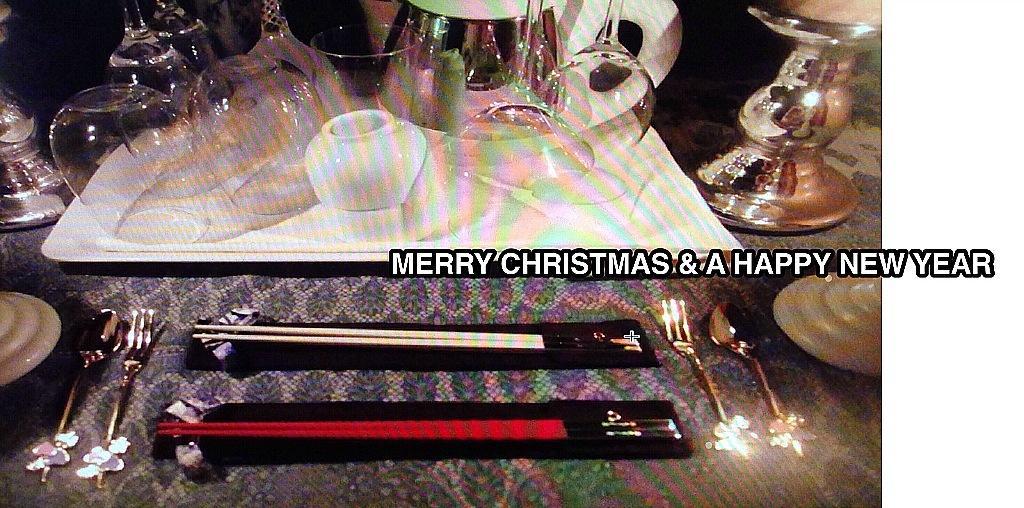Can you describe this image briefly? In this image there is a cloth, there are chopsticks, there are forks, there are spoons, there is an object there looks like a saucer is towards the right of the image, there is a tray, there are glasses, there is a jug, there is a metal object towards the top of the image, there is a metal object towards the left of the image, there is text. 